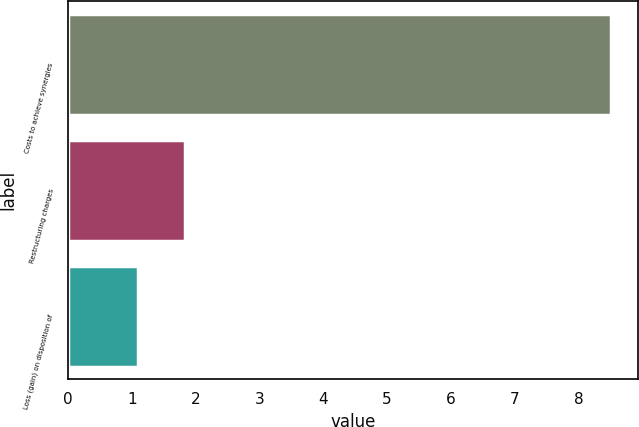Convert chart. <chart><loc_0><loc_0><loc_500><loc_500><bar_chart><fcel>Costs to achieve synergies<fcel>Restructuring charges<fcel>Loss (gain) on disposition of<nl><fcel>8.5<fcel>1.84<fcel>1.1<nl></chart> 